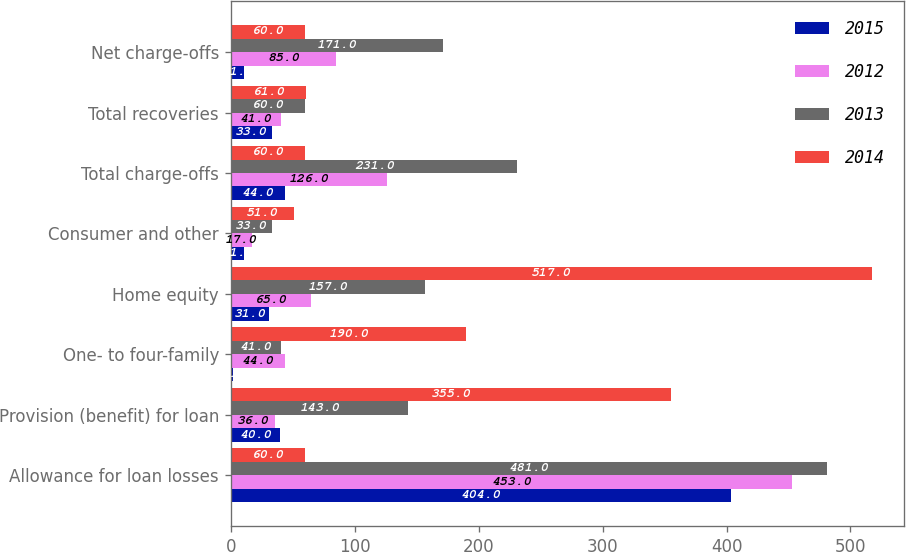<chart> <loc_0><loc_0><loc_500><loc_500><stacked_bar_chart><ecel><fcel>Allowance for loan losses<fcel>Provision (benefit) for loan<fcel>One- to four-family<fcel>Home equity<fcel>Consumer and other<fcel>Total charge-offs<fcel>Total recoveries<fcel>Net charge-offs<nl><fcel>2015<fcel>404<fcel>40<fcel>2<fcel>31<fcel>11<fcel>44<fcel>33<fcel>11<nl><fcel>2012<fcel>453<fcel>36<fcel>44<fcel>65<fcel>17<fcel>126<fcel>41<fcel>85<nl><fcel>2013<fcel>481<fcel>143<fcel>41<fcel>157<fcel>33<fcel>231<fcel>60<fcel>171<nl><fcel>2014<fcel>60<fcel>355<fcel>190<fcel>517<fcel>51<fcel>60<fcel>61<fcel>60<nl></chart> 